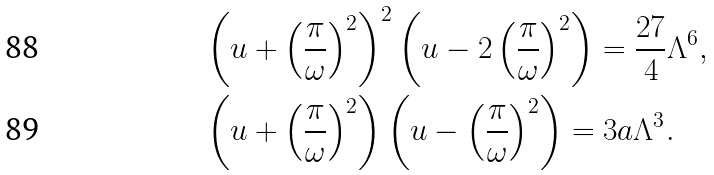<formula> <loc_0><loc_0><loc_500><loc_500>& \left ( { u } + \left ( \frac { \pi } \omega \right ) ^ { 2 } \right ) ^ { 2 } \left ( { u } - 2 \left ( \frac { \pi } \omega \right ) ^ { 2 } \right ) = \frac { 2 7 } 4 \Lambda ^ { 6 } , \\ & \left ( { u } + \left ( \frac { \pi } \omega \right ) ^ { 2 } \right ) \left ( { u } - \left ( \frac { \pi } \omega \right ) ^ { 2 } \right ) = 3 a \Lambda ^ { 3 } .</formula> 